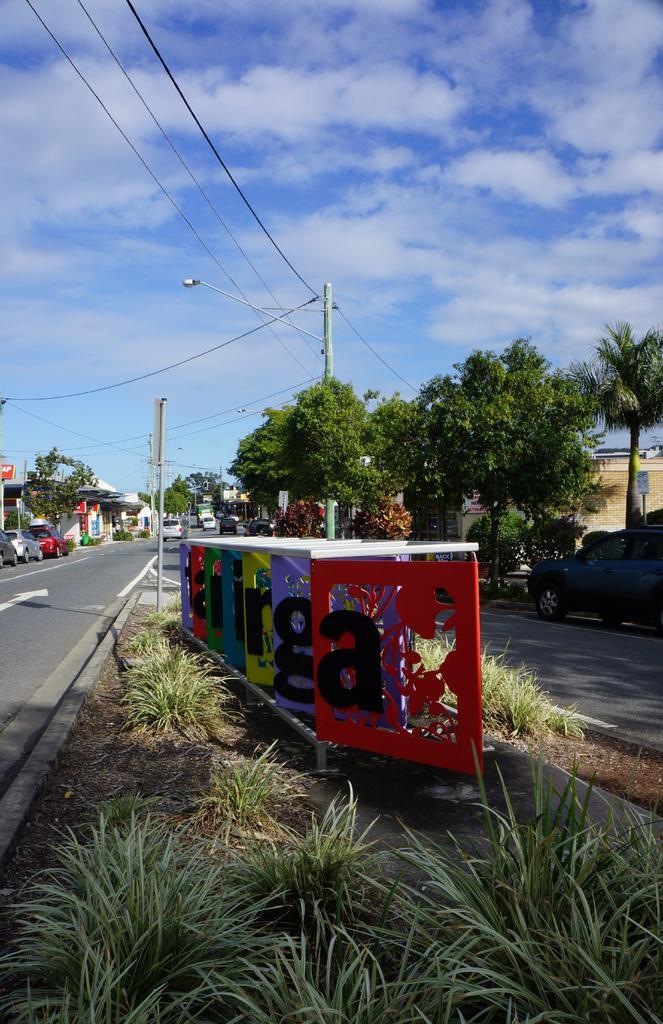Describe this image in one or two sentences. In this image there is a road, on which there are some vehicles, poles, power line cables, beside the road there are some trees, buildings, at the top there is the sky, in the foreground there is grass, boards, on which there are some letters. 